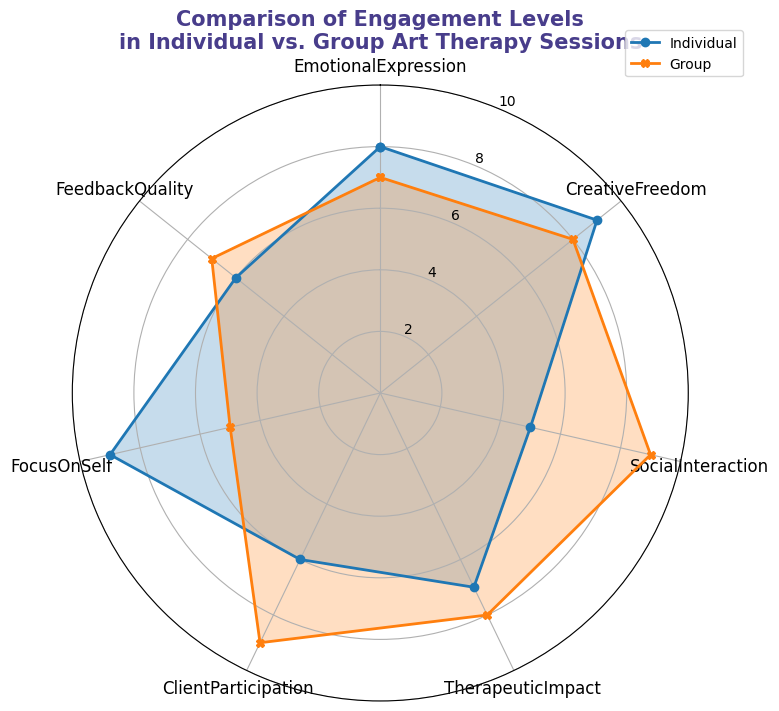Which session type has a higher value for Social Interaction? Look at the radar chart and compare the values for Social Interaction. The Group session has a value of 9 while the Individual session has a value of 5.
Answer: Group How many attributes have a higher value for Group sessions than Individual sessions? Count the attributes where the Group value is higher than the Individual value by comparing them one by one: Emotional Expression (Group: 7 < Individual: 8), Creative Freedom (Group: 8 < Individual: 9), Social Interaction (Group: 9 > Individual: 5), Therapeutic Impact (Group: 8 > Individual: 7), Client Participation (Group: 9 > Individual: 6), Focus On Self (Group: 5 < Individual: 9), Feedback Quality (Group: 7 > Individual: 6). So, 4 attributes have higher values for Group sessions.
Answer: 4 What is the average value of Client Participation for both Individual and Group sessions? Add the Client Participation values for both sessions and divide by 2. Individual: 6, Group: 9. (6 + 9) / 2 = 7.5.
Answer: 7.5 What is the combined total value for Therapeutic Impact for both Individual and Group sessions? Add the Therapeutic Impact values for both sessions. Individual: 7, Group: 8. 7 + 8 = 15.
Answer: 15 For which attribute is the Individual session's value the highest? Look at the radar chart and identify the highest value for Individual sessions among all attributes. The highest value is 9 for Creative Freedom and Focus On Self.
Answer: Creative Freedom, Focus On Self Which session type has a higher average value across all attributes? Calculate the average value for each session type. Individual: (8 + 9 + 5 + 7 + 6 + 9 + 6) / 7 ≈ 7.14, Group: (7 + 8 + 9 + 8 + 9 + 5 + 7) / 7 ≈ 7.57. Group sessions have the higher average value.
Answer: Group 